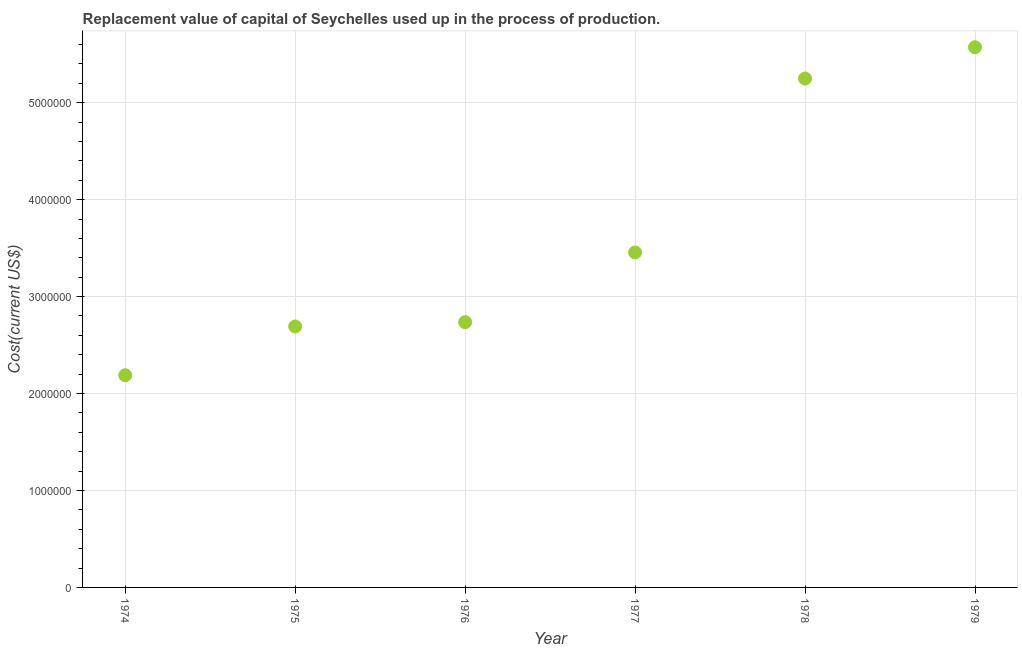What is the consumption of fixed capital in 1976?
Ensure brevity in your answer.  2.74e+06. Across all years, what is the maximum consumption of fixed capital?
Keep it short and to the point. 5.57e+06. Across all years, what is the minimum consumption of fixed capital?
Ensure brevity in your answer.  2.19e+06. In which year was the consumption of fixed capital maximum?
Offer a very short reply. 1979. In which year was the consumption of fixed capital minimum?
Your answer should be very brief. 1974. What is the sum of the consumption of fixed capital?
Provide a succinct answer. 2.19e+07. What is the difference between the consumption of fixed capital in 1974 and 1977?
Keep it short and to the point. -1.27e+06. What is the average consumption of fixed capital per year?
Offer a terse response. 3.65e+06. What is the median consumption of fixed capital?
Give a very brief answer. 3.10e+06. Do a majority of the years between 1975 and 1974 (inclusive) have consumption of fixed capital greater than 3600000 US$?
Make the answer very short. No. What is the ratio of the consumption of fixed capital in 1976 to that in 1977?
Your response must be concise. 0.79. Is the difference between the consumption of fixed capital in 1974 and 1977 greater than the difference between any two years?
Your answer should be very brief. No. What is the difference between the highest and the second highest consumption of fixed capital?
Offer a terse response. 3.23e+05. Is the sum of the consumption of fixed capital in 1975 and 1978 greater than the maximum consumption of fixed capital across all years?
Provide a short and direct response. Yes. What is the difference between the highest and the lowest consumption of fixed capital?
Offer a very short reply. 3.38e+06. In how many years, is the consumption of fixed capital greater than the average consumption of fixed capital taken over all years?
Your answer should be compact. 2. How many dotlines are there?
Your response must be concise. 1. Are the values on the major ticks of Y-axis written in scientific E-notation?
Ensure brevity in your answer.  No. Does the graph contain any zero values?
Offer a terse response. No. What is the title of the graph?
Provide a short and direct response. Replacement value of capital of Seychelles used up in the process of production. What is the label or title of the X-axis?
Your response must be concise. Year. What is the label or title of the Y-axis?
Your response must be concise. Cost(current US$). What is the Cost(current US$) in 1974?
Ensure brevity in your answer.  2.19e+06. What is the Cost(current US$) in 1975?
Provide a succinct answer. 2.69e+06. What is the Cost(current US$) in 1976?
Give a very brief answer. 2.74e+06. What is the Cost(current US$) in 1977?
Offer a terse response. 3.46e+06. What is the Cost(current US$) in 1978?
Provide a succinct answer. 5.25e+06. What is the Cost(current US$) in 1979?
Make the answer very short. 5.57e+06. What is the difference between the Cost(current US$) in 1974 and 1975?
Your answer should be compact. -5.03e+05. What is the difference between the Cost(current US$) in 1974 and 1976?
Give a very brief answer. -5.48e+05. What is the difference between the Cost(current US$) in 1974 and 1977?
Your response must be concise. -1.27e+06. What is the difference between the Cost(current US$) in 1974 and 1978?
Give a very brief answer. -3.06e+06. What is the difference between the Cost(current US$) in 1974 and 1979?
Keep it short and to the point. -3.38e+06. What is the difference between the Cost(current US$) in 1975 and 1976?
Offer a very short reply. -4.44e+04. What is the difference between the Cost(current US$) in 1975 and 1977?
Give a very brief answer. -7.64e+05. What is the difference between the Cost(current US$) in 1975 and 1978?
Offer a very short reply. -2.56e+06. What is the difference between the Cost(current US$) in 1975 and 1979?
Give a very brief answer. -2.88e+06. What is the difference between the Cost(current US$) in 1976 and 1977?
Provide a succinct answer. -7.19e+05. What is the difference between the Cost(current US$) in 1976 and 1978?
Ensure brevity in your answer.  -2.51e+06. What is the difference between the Cost(current US$) in 1976 and 1979?
Your response must be concise. -2.84e+06. What is the difference between the Cost(current US$) in 1977 and 1978?
Offer a very short reply. -1.79e+06. What is the difference between the Cost(current US$) in 1977 and 1979?
Your answer should be very brief. -2.12e+06. What is the difference between the Cost(current US$) in 1978 and 1979?
Make the answer very short. -3.23e+05. What is the ratio of the Cost(current US$) in 1974 to that in 1975?
Your answer should be compact. 0.81. What is the ratio of the Cost(current US$) in 1974 to that in 1976?
Offer a very short reply. 0.8. What is the ratio of the Cost(current US$) in 1974 to that in 1977?
Give a very brief answer. 0.63. What is the ratio of the Cost(current US$) in 1974 to that in 1978?
Make the answer very short. 0.42. What is the ratio of the Cost(current US$) in 1974 to that in 1979?
Give a very brief answer. 0.39. What is the ratio of the Cost(current US$) in 1975 to that in 1976?
Your answer should be compact. 0.98. What is the ratio of the Cost(current US$) in 1975 to that in 1977?
Offer a terse response. 0.78. What is the ratio of the Cost(current US$) in 1975 to that in 1978?
Give a very brief answer. 0.51. What is the ratio of the Cost(current US$) in 1975 to that in 1979?
Your answer should be very brief. 0.48. What is the ratio of the Cost(current US$) in 1976 to that in 1977?
Give a very brief answer. 0.79. What is the ratio of the Cost(current US$) in 1976 to that in 1978?
Provide a short and direct response. 0.52. What is the ratio of the Cost(current US$) in 1976 to that in 1979?
Your answer should be very brief. 0.49. What is the ratio of the Cost(current US$) in 1977 to that in 1978?
Provide a succinct answer. 0.66. What is the ratio of the Cost(current US$) in 1977 to that in 1979?
Your answer should be compact. 0.62. What is the ratio of the Cost(current US$) in 1978 to that in 1979?
Make the answer very short. 0.94. 